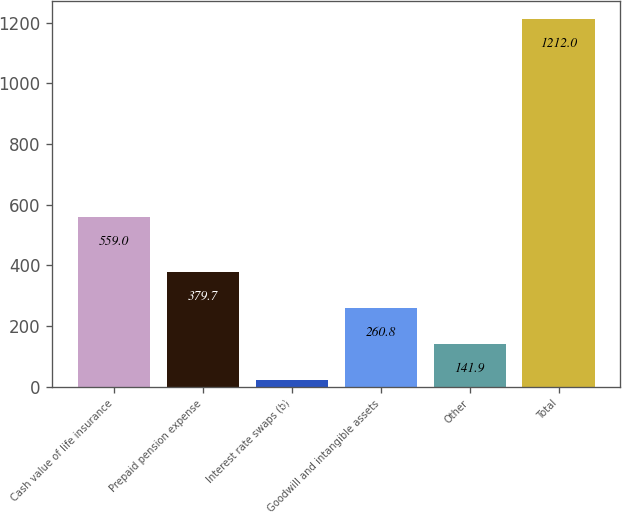Convert chart. <chart><loc_0><loc_0><loc_500><loc_500><bar_chart><fcel>Cash value of life insurance<fcel>Prepaid pension expense<fcel>Interest rate swaps (b)<fcel>Goodwill and intangible assets<fcel>Other<fcel>Total<nl><fcel>559<fcel>379.7<fcel>23<fcel>260.8<fcel>141.9<fcel>1212<nl></chart> 